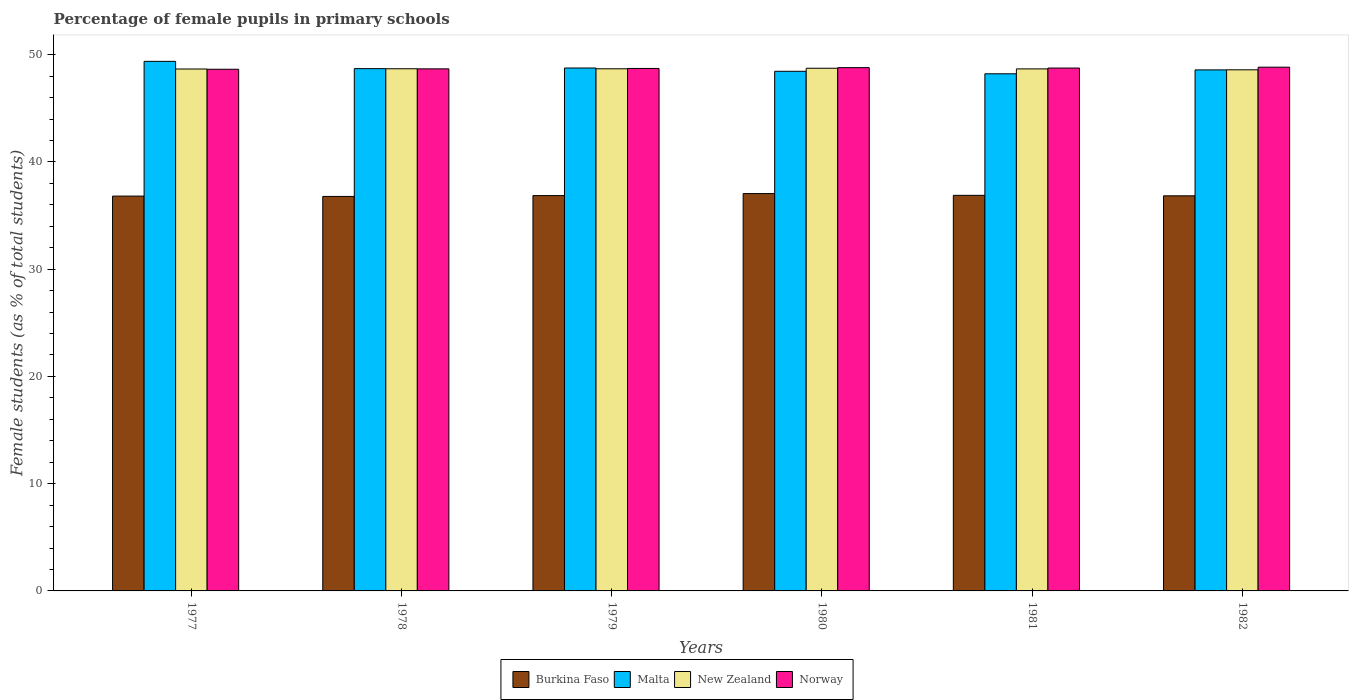Are the number of bars on each tick of the X-axis equal?
Offer a very short reply. Yes. How many bars are there on the 6th tick from the left?
Give a very brief answer. 4. How many bars are there on the 1st tick from the right?
Keep it short and to the point. 4. What is the percentage of female pupils in primary schools in Malta in 1981?
Make the answer very short. 48.22. Across all years, what is the maximum percentage of female pupils in primary schools in New Zealand?
Provide a short and direct response. 48.74. Across all years, what is the minimum percentage of female pupils in primary schools in Norway?
Your answer should be compact. 48.65. In which year was the percentage of female pupils in primary schools in New Zealand minimum?
Give a very brief answer. 1982. What is the total percentage of female pupils in primary schools in New Zealand in the graph?
Provide a short and direct response. 292.06. What is the difference between the percentage of female pupils in primary schools in Norway in 1980 and that in 1981?
Offer a very short reply. 0.04. What is the difference between the percentage of female pupils in primary schools in New Zealand in 1978 and the percentage of female pupils in primary schools in Norway in 1980?
Make the answer very short. -0.1. What is the average percentage of female pupils in primary schools in Burkina Faso per year?
Offer a very short reply. 36.88. In the year 1981, what is the difference between the percentage of female pupils in primary schools in New Zealand and percentage of female pupils in primary schools in Burkina Faso?
Offer a very short reply. 11.79. In how many years, is the percentage of female pupils in primary schools in New Zealand greater than 42 %?
Ensure brevity in your answer.  6. What is the ratio of the percentage of female pupils in primary schools in Malta in 1977 to that in 1981?
Your response must be concise. 1.02. What is the difference between the highest and the second highest percentage of female pupils in primary schools in Burkina Faso?
Keep it short and to the point. 0.16. What is the difference between the highest and the lowest percentage of female pupils in primary schools in New Zealand?
Provide a succinct answer. 0.14. In how many years, is the percentage of female pupils in primary schools in Burkina Faso greater than the average percentage of female pupils in primary schools in Burkina Faso taken over all years?
Keep it short and to the point. 2. Is it the case that in every year, the sum of the percentage of female pupils in primary schools in Malta and percentage of female pupils in primary schools in Norway is greater than the sum of percentage of female pupils in primary schools in Burkina Faso and percentage of female pupils in primary schools in New Zealand?
Provide a short and direct response. Yes. What does the 2nd bar from the left in 1977 represents?
Ensure brevity in your answer.  Malta. Is it the case that in every year, the sum of the percentage of female pupils in primary schools in Malta and percentage of female pupils in primary schools in Burkina Faso is greater than the percentage of female pupils in primary schools in Norway?
Your answer should be compact. Yes. How many bars are there?
Offer a very short reply. 24. Are all the bars in the graph horizontal?
Keep it short and to the point. No. What is the difference between two consecutive major ticks on the Y-axis?
Offer a very short reply. 10. Does the graph contain any zero values?
Keep it short and to the point. No. Does the graph contain grids?
Offer a very short reply. No. Where does the legend appear in the graph?
Keep it short and to the point. Bottom center. What is the title of the graph?
Your response must be concise. Percentage of female pupils in primary schools. Does "World" appear as one of the legend labels in the graph?
Offer a terse response. No. What is the label or title of the X-axis?
Provide a succinct answer. Years. What is the label or title of the Y-axis?
Make the answer very short. Female students (as % of total students). What is the Female students (as % of total students) of Burkina Faso in 1977?
Your answer should be very brief. 36.82. What is the Female students (as % of total students) of Malta in 1977?
Your answer should be very brief. 49.38. What is the Female students (as % of total students) of New Zealand in 1977?
Provide a short and direct response. 48.67. What is the Female students (as % of total students) in Norway in 1977?
Offer a very short reply. 48.65. What is the Female students (as % of total students) of Burkina Faso in 1978?
Your response must be concise. 36.79. What is the Female students (as % of total students) in Malta in 1978?
Provide a short and direct response. 48.7. What is the Female students (as % of total students) of New Zealand in 1978?
Offer a very short reply. 48.69. What is the Female students (as % of total students) in Norway in 1978?
Provide a short and direct response. 48.68. What is the Female students (as % of total students) in Burkina Faso in 1979?
Your response must be concise. 36.87. What is the Female students (as % of total students) of Malta in 1979?
Provide a succinct answer. 48.76. What is the Female students (as % of total students) of New Zealand in 1979?
Give a very brief answer. 48.69. What is the Female students (as % of total students) in Norway in 1979?
Keep it short and to the point. 48.72. What is the Female students (as % of total students) of Burkina Faso in 1980?
Provide a succinct answer. 37.05. What is the Female students (as % of total students) in Malta in 1980?
Make the answer very short. 48.46. What is the Female students (as % of total students) of New Zealand in 1980?
Your answer should be compact. 48.74. What is the Female students (as % of total students) of Norway in 1980?
Your answer should be very brief. 48.8. What is the Female students (as % of total students) in Burkina Faso in 1981?
Keep it short and to the point. 36.89. What is the Female students (as % of total students) in Malta in 1981?
Offer a terse response. 48.22. What is the Female students (as % of total students) in New Zealand in 1981?
Provide a succinct answer. 48.68. What is the Female students (as % of total students) in Norway in 1981?
Your answer should be very brief. 48.76. What is the Female students (as % of total students) in Burkina Faso in 1982?
Your answer should be compact. 36.84. What is the Female students (as % of total students) in Malta in 1982?
Give a very brief answer. 48.59. What is the Female students (as % of total students) in New Zealand in 1982?
Give a very brief answer. 48.59. What is the Female students (as % of total students) of Norway in 1982?
Provide a short and direct response. 48.84. Across all years, what is the maximum Female students (as % of total students) in Burkina Faso?
Offer a terse response. 37.05. Across all years, what is the maximum Female students (as % of total students) of Malta?
Offer a terse response. 49.38. Across all years, what is the maximum Female students (as % of total students) of New Zealand?
Make the answer very short. 48.74. Across all years, what is the maximum Female students (as % of total students) of Norway?
Provide a short and direct response. 48.84. Across all years, what is the minimum Female students (as % of total students) of Burkina Faso?
Keep it short and to the point. 36.79. Across all years, what is the minimum Female students (as % of total students) of Malta?
Your response must be concise. 48.22. Across all years, what is the minimum Female students (as % of total students) in New Zealand?
Give a very brief answer. 48.59. Across all years, what is the minimum Female students (as % of total students) in Norway?
Give a very brief answer. 48.65. What is the total Female students (as % of total students) of Burkina Faso in the graph?
Provide a short and direct response. 221.26. What is the total Female students (as % of total students) of Malta in the graph?
Your answer should be compact. 292.11. What is the total Female students (as % of total students) of New Zealand in the graph?
Offer a terse response. 292.06. What is the total Female students (as % of total students) of Norway in the graph?
Your answer should be very brief. 292.44. What is the difference between the Female students (as % of total students) of Burkina Faso in 1977 and that in 1978?
Make the answer very short. 0.03. What is the difference between the Female students (as % of total students) in Malta in 1977 and that in 1978?
Your response must be concise. 0.68. What is the difference between the Female students (as % of total students) in New Zealand in 1977 and that in 1978?
Your response must be concise. -0.02. What is the difference between the Female students (as % of total students) of Norway in 1977 and that in 1978?
Keep it short and to the point. -0.04. What is the difference between the Female students (as % of total students) of Burkina Faso in 1977 and that in 1979?
Your response must be concise. -0.05. What is the difference between the Female students (as % of total students) in Malta in 1977 and that in 1979?
Your answer should be very brief. 0.62. What is the difference between the Female students (as % of total students) in New Zealand in 1977 and that in 1979?
Your response must be concise. -0.02. What is the difference between the Female students (as % of total students) in Norway in 1977 and that in 1979?
Offer a terse response. -0.07. What is the difference between the Female students (as % of total students) in Burkina Faso in 1977 and that in 1980?
Offer a terse response. -0.23. What is the difference between the Female students (as % of total students) in Malta in 1977 and that in 1980?
Offer a very short reply. 0.93. What is the difference between the Female students (as % of total students) in New Zealand in 1977 and that in 1980?
Give a very brief answer. -0.07. What is the difference between the Female students (as % of total students) of Norway in 1977 and that in 1980?
Your response must be concise. -0.15. What is the difference between the Female students (as % of total students) in Burkina Faso in 1977 and that in 1981?
Make the answer very short. -0.07. What is the difference between the Female students (as % of total students) in Malta in 1977 and that in 1981?
Your answer should be compact. 1.16. What is the difference between the Female students (as % of total students) in New Zealand in 1977 and that in 1981?
Ensure brevity in your answer.  -0.01. What is the difference between the Female students (as % of total students) of Norway in 1977 and that in 1981?
Ensure brevity in your answer.  -0.11. What is the difference between the Female students (as % of total students) of Burkina Faso in 1977 and that in 1982?
Give a very brief answer. -0.03. What is the difference between the Female students (as % of total students) in Malta in 1977 and that in 1982?
Keep it short and to the point. 0.8. What is the difference between the Female students (as % of total students) in New Zealand in 1977 and that in 1982?
Make the answer very short. 0.07. What is the difference between the Female students (as % of total students) of Norway in 1977 and that in 1982?
Offer a terse response. -0.19. What is the difference between the Female students (as % of total students) of Burkina Faso in 1978 and that in 1979?
Ensure brevity in your answer.  -0.08. What is the difference between the Female students (as % of total students) of Malta in 1978 and that in 1979?
Offer a terse response. -0.06. What is the difference between the Female students (as % of total students) in New Zealand in 1978 and that in 1979?
Provide a short and direct response. 0. What is the difference between the Female students (as % of total students) in Norway in 1978 and that in 1979?
Offer a terse response. -0.04. What is the difference between the Female students (as % of total students) of Burkina Faso in 1978 and that in 1980?
Your answer should be very brief. -0.26. What is the difference between the Female students (as % of total students) in Malta in 1978 and that in 1980?
Offer a very short reply. 0.25. What is the difference between the Female students (as % of total students) of New Zealand in 1978 and that in 1980?
Your response must be concise. -0.05. What is the difference between the Female students (as % of total students) of Norway in 1978 and that in 1980?
Give a very brief answer. -0.11. What is the difference between the Female students (as % of total students) of Burkina Faso in 1978 and that in 1981?
Provide a succinct answer. -0.1. What is the difference between the Female students (as % of total students) of Malta in 1978 and that in 1981?
Offer a terse response. 0.48. What is the difference between the Female students (as % of total students) in New Zealand in 1978 and that in 1981?
Offer a terse response. 0.01. What is the difference between the Female students (as % of total students) of Norway in 1978 and that in 1981?
Your answer should be very brief. -0.08. What is the difference between the Female students (as % of total students) of Burkina Faso in 1978 and that in 1982?
Your answer should be very brief. -0.06. What is the difference between the Female students (as % of total students) in Malta in 1978 and that in 1982?
Keep it short and to the point. 0.12. What is the difference between the Female students (as % of total students) in New Zealand in 1978 and that in 1982?
Keep it short and to the point. 0.1. What is the difference between the Female students (as % of total students) in Norway in 1978 and that in 1982?
Ensure brevity in your answer.  -0.16. What is the difference between the Female students (as % of total students) of Burkina Faso in 1979 and that in 1980?
Your answer should be very brief. -0.19. What is the difference between the Female students (as % of total students) in Malta in 1979 and that in 1980?
Ensure brevity in your answer.  0.31. What is the difference between the Female students (as % of total students) of New Zealand in 1979 and that in 1980?
Your answer should be very brief. -0.05. What is the difference between the Female students (as % of total students) in Norway in 1979 and that in 1980?
Your answer should be compact. -0.08. What is the difference between the Female students (as % of total students) in Burkina Faso in 1979 and that in 1981?
Your response must be concise. -0.02. What is the difference between the Female students (as % of total students) of Malta in 1979 and that in 1981?
Make the answer very short. 0.54. What is the difference between the Female students (as % of total students) of Norway in 1979 and that in 1981?
Your response must be concise. -0.04. What is the difference between the Female students (as % of total students) in Burkina Faso in 1979 and that in 1982?
Provide a short and direct response. 0.02. What is the difference between the Female students (as % of total students) of Malta in 1979 and that in 1982?
Provide a short and direct response. 0.18. What is the difference between the Female students (as % of total students) in New Zealand in 1979 and that in 1982?
Offer a very short reply. 0.09. What is the difference between the Female students (as % of total students) in Norway in 1979 and that in 1982?
Your answer should be compact. -0.12. What is the difference between the Female students (as % of total students) in Burkina Faso in 1980 and that in 1981?
Your response must be concise. 0.16. What is the difference between the Female students (as % of total students) of Malta in 1980 and that in 1981?
Your answer should be compact. 0.23. What is the difference between the Female students (as % of total students) in New Zealand in 1980 and that in 1981?
Your response must be concise. 0.06. What is the difference between the Female students (as % of total students) in Norway in 1980 and that in 1981?
Provide a succinct answer. 0.04. What is the difference between the Female students (as % of total students) in Burkina Faso in 1980 and that in 1982?
Provide a short and direct response. 0.21. What is the difference between the Female students (as % of total students) in Malta in 1980 and that in 1982?
Your response must be concise. -0.13. What is the difference between the Female students (as % of total students) in New Zealand in 1980 and that in 1982?
Your response must be concise. 0.14. What is the difference between the Female students (as % of total students) of Norway in 1980 and that in 1982?
Your answer should be compact. -0.04. What is the difference between the Female students (as % of total students) in Burkina Faso in 1981 and that in 1982?
Your response must be concise. 0.05. What is the difference between the Female students (as % of total students) in Malta in 1981 and that in 1982?
Your answer should be compact. -0.36. What is the difference between the Female students (as % of total students) of New Zealand in 1981 and that in 1982?
Your answer should be compact. 0.08. What is the difference between the Female students (as % of total students) of Norway in 1981 and that in 1982?
Offer a terse response. -0.08. What is the difference between the Female students (as % of total students) of Burkina Faso in 1977 and the Female students (as % of total students) of Malta in 1978?
Your response must be concise. -11.89. What is the difference between the Female students (as % of total students) of Burkina Faso in 1977 and the Female students (as % of total students) of New Zealand in 1978?
Provide a succinct answer. -11.87. What is the difference between the Female students (as % of total students) in Burkina Faso in 1977 and the Female students (as % of total students) in Norway in 1978?
Make the answer very short. -11.87. What is the difference between the Female students (as % of total students) of Malta in 1977 and the Female students (as % of total students) of New Zealand in 1978?
Keep it short and to the point. 0.69. What is the difference between the Female students (as % of total students) of Malta in 1977 and the Female students (as % of total students) of Norway in 1978?
Your response must be concise. 0.7. What is the difference between the Female students (as % of total students) of New Zealand in 1977 and the Female students (as % of total students) of Norway in 1978?
Provide a succinct answer. -0.01. What is the difference between the Female students (as % of total students) in Burkina Faso in 1977 and the Female students (as % of total students) in Malta in 1979?
Keep it short and to the point. -11.94. What is the difference between the Female students (as % of total students) in Burkina Faso in 1977 and the Female students (as % of total students) in New Zealand in 1979?
Provide a short and direct response. -11.87. What is the difference between the Female students (as % of total students) in Burkina Faso in 1977 and the Female students (as % of total students) in Norway in 1979?
Offer a very short reply. -11.9. What is the difference between the Female students (as % of total students) of Malta in 1977 and the Female students (as % of total students) of New Zealand in 1979?
Make the answer very short. 0.69. What is the difference between the Female students (as % of total students) of Malta in 1977 and the Female students (as % of total students) of Norway in 1979?
Keep it short and to the point. 0.66. What is the difference between the Female students (as % of total students) of New Zealand in 1977 and the Female students (as % of total students) of Norway in 1979?
Offer a very short reply. -0.05. What is the difference between the Female students (as % of total students) in Burkina Faso in 1977 and the Female students (as % of total students) in Malta in 1980?
Provide a short and direct response. -11.64. What is the difference between the Female students (as % of total students) in Burkina Faso in 1977 and the Female students (as % of total students) in New Zealand in 1980?
Provide a short and direct response. -11.92. What is the difference between the Female students (as % of total students) of Burkina Faso in 1977 and the Female students (as % of total students) of Norway in 1980?
Provide a succinct answer. -11.98. What is the difference between the Female students (as % of total students) in Malta in 1977 and the Female students (as % of total students) in New Zealand in 1980?
Offer a very short reply. 0.64. What is the difference between the Female students (as % of total students) in Malta in 1977 and the Female students (as % of total students) in Norway in 1980?
Your answer should be very brief. 0.59. What is the difference between the Female students (as % of total students) in New Zealand in 1977 and the Female students (as % of total students) in Norway in 1980?
Make the answer very short. -0.13. What is the difference between the Female students (as % of total students) in Burkina Faso in 1977 and the Female students (as % of total students) in Malta in 1981?
Your answer should be very brief. -11.4. What is the difference between the Female students (as % of total students) in Burkina Faso in 1977 and the Female students (as % of total students) in New Zealand in 1981?
Ensure brevity in your answer.  -11.86. What is the difference between the Female students (as % of total students) in Burkina Faso in 1977 and the Female students (as % of total students) in Norway in 1981?
Ensure brevity in your answer.  -11.94. What is the difference between the Female students (as % of total students) of Malta in 1977 and the Female students (as % of total students) of New Zealand in 1981?
Make the answer very short. 0.7. What is the difference between the Female students (as % of total students) of Malta in 1977 and the Female students (as % of total students) of Norway in 1981?
Your answer should be very brief. 0.62. What is the difference between the Female students (as % of total students) of New Zealand in 1977 and the Female students (as % of total students) of Norway in 1981?
Keep it short and to the point. -0.09. What is the difference between the Female students (as % of total students) in Burkina Faso in 1977 and the Female students (as % of total students) in Malta in 1982?
Make the answer very short. -11.77. What is the difference between the Female students (as % of total students) of Burkina Faso in 1977 and the Female students (as % of total students) of New Zealand in 1982?
Give a very brief answer. -11.78. What is the difference between the Female students (as % of total students) of Burkina Faso in 1977 and the Female students (as % of total students) of Norway in 1982?
Offer a very short reply. -12.02. What is the difference between the Female students (as % of total students) of Malta in 1977 and the Female students (as % of total students) of New Zealand in 1982?
Keep it short and to the point. 0.79. What is the difference between the Female students (as % of total students) of Malta in 1977 and the Female students (as % of total students) of Norway in 1982?
Provide a succinct answer. 0.54. What is the difference between the Female students (as % of total students) in New Zealand in 1977 and the Female students (as % of total students) in Norway in 1982?
Keep it short and to the point. -0.17. What is the difference between the Female students (as % of total students) in Burkina Faso in 1978 and the Female students (as % of total students) in Malta in 1979?
Provide a short and direct response. -11.97. What is the difference between the Female students (as % of total students) in Burkina Faso in 1978 and the Female students (as % of total students) in New Zealand in 1979?
Offer a terse response. -11.9. What is the difference between the Female students (as % of total students) of Burkina Faso in 1978 and the Female students (as % of total students) of Norway in 1979?
Provide a succinct answer. -11.93. What is the difference between the Female students (as % of total students) of Malta in 1978 and the Female students (as % of total students) of New Zealand in 1979?
Offer a very short reply. 0.01. What is the difference between the Female students (as % of total students) of Malta in 1978 and the Female students (as % of total students) of Norway in 1979?
Make the answer very short. -0.02. What is the difference between the Female students (as % of total students) in New Zealand in 1978 and the Female students (as % of total students) in Norway in 1979?
Your response must be concise. -0.03. What is the difference between the Female students (as % of total students) in Burkina Faso in 1978 and the Female students (as % of total students) in Malta in 1980?
Offer a terse response. -11.67. What is the difference between the Female students (as % of total students) of Burkina Faso in 1978 and the Female students (as % of total students) of New Zealand in 1980?
Provide a succinct answer. -11.95. What is the difference between the Female students (as % of total students) of Burkina Faso in 1978 and the Female students (as % of total students) of Norway in 1980?
Provide a short and direct response. -12.01. What is the difference between the Female students (as % of total students) of Malta in 1978 and the Female students (as % of total students) of New Zealand in 1980?
Give a very brief answer. -0.04. What is the difference between the Female students (as % of total students) in Malta in 1978 and the Female students (as % of total students) in Norway in 1980?
Give a very brief answer. -0.09. What is the difference between the Female students (as % of total students) in New Zealand in 1978 and the Female students (as % of total students) in Norway in 1980?
Ensure brevity in your answer.  -0.1. What is the difference between the Female students (as % of total students) in Burkina Faso in 1978 and the Female students (as % of total students) in Malta in 1981?
Your answer should be very brief. -11.44. What is the difference between the Female students (as % of total students) in Burkina Faso in 1978 and the Female students (as % of total students) in New Zealand in 1981?
Give a very brief answer. -11.89. What is the difference between the Female students (as % of total students) of Burkina Faso in 1978 and the Female students (as % of total students) of Norway in 1981?
Provide a short and direct response. -11.97. What is the difference between the Female students (as % of total students) of Malta in 1978 and the Female students (as % of total students) of New Zealand in 1981?
Your answer should be very brief. 0.02. What is the difference between the Female students (as % of total students) of Malta in 1978 and the Female students (as % of total students) of Norway in 1981?
Provide a short and direct response. -0.06. What is the difference between the Female students (as % of total students) of New Zealand in 1978 and the Female students (as % of total students) of Norway in 1981?
Offer a terse response. -0.07. What is the difference between the Female students (as % of total students) in Burkina Faso in 1978 and the Female students (as % of total students) in Malta in 1982?
Ensure brevity in your answer.  -11.8. What is the difference between the Female students (as % of total students) in Burkina Faso in 1978 and the Female students (as % of total students) in New Zealand in 1982?
Ensure brevity in your answer.  -11.81. What is the difference between the Female students (as % of total students) in Burkina Faso in 1978 and the Female students (as % of total students) in Norway in 1982?
Make the answer very short. -12.05. What is the difference between the Female students (as % of total students) in Malta in 1978 and the Female students (as % of total students) in New Zealand in 1982?
Your answer should be very brief. 0.11. What is the difference between the Female students (as % of total students) in Malta in 1978 and the Female students (as % of total students) in Norway in 1982?
Ensure brevity in your answer.  -0.14. What is the difference between the Female students (as % of total students) of New Zealand in 1978 and the Female students (as % of total students) of Norway in 1982?
Your response must be concise. -0.15. What is the difference between the Female students (as % of total students) in Burkina Faso in 1979 and the Female students (as % of total students) in Malta in 1980?
Make the answer very short. -11.59. What is the difference between the Female students (as % of total students) of Burkina Faso in 1979 and the Female students (as % of total students) of New Zealand in 1980?
Your answer should be compact. -11.87. What is the difference between the Female students (as % of total students) of Burkina Faso in 1979 and the Female students (as % of total students) of Norway in 1980?
Your answer should be compact. -11.93. What is the difference between the Female students (as % of total students) of Malta in 1979 and the Female students (as % of total students) of New Zealand in 1980?
Ensure brevity in your answer.  0.02. What is the difference between the Female students (as % of total students) in Malta in 1979 and the Female students (as % of total students) in Norway in 1980?
Your answer should be compact. -0.04. What is the difference between the Female students (as % of total students) of New Zealand in 1979 and the Female students (as % of total students) of Norway in 1980?
Provide a short and direct response. -0.11. What is the difference between the Female students (as % of total students) in Burkina Faso in 1979 and the Female students (as % of total students) in Malta in 1981?
Ensure brevity in your answer.  -11.36. What is the difference between the Female students (as % of total students) in Burkina Faso in 1979 and the Female students (as % of total students) in New Zealand in 1981?
Provide a short and direct response. -11.81. What is the difference between the Female students (as % of total students) of Burkina Faso in 1979 and the Female students (as % of total students) of Norway in 1981?
Keep it short and to the point. -11.89. What is the difference between the Female students (as % of total students) of Malta in 1979 and the Female students (as % of total students) of New Zealand in 1981?
Give a very brief answer. 0.08. What is the difference between the Female students (as % of total students) in Malta in 1979 and the Female students (as % of total students) in Norway in 1981?
Ensure brevity in your answer.  0. What is the difference between the Female students (as % of total students) of New Zealand in 1979 and the Female students (as % of total students) of Norway in 1981?
Make the answer very short. -0.07. What is the difference between the Female students (as % of total students) in Burkina Faso in 1979 and the Female students (as % of total students) in Malta in 1982?
Your answer should be very brief. -11.72. What is the difference between the Female students (as % of total students) of Burkina Faso in 1979 and the Female students (as % of total students) of New Zealand in 1982?
Offer a very short reply. -11.73. What is the difference between the Female students (as % of total students) in Burkina Faso in 1979 and the Female students (as % of total students) in Norway in 1982?
Your answer should be very brief. -11.97. What is the difference between the Female students (as % of total students) of Malta in 1979 and the Female students (as % of total students) of New Zealand in 1982?
Make the answer very short. 0.17. What is the difference between the Female students (as % of total students) in Malta in 1979 and the Female students (as % of total students) in Norway in 1982?
Your answer should be very brief. -0.08. What is the difference between the Female students (as % of total students) in New Zealand in 1979 and the Female students (as % of total students) in Norway in 1982?
Provide a short and direct response. -0.15. What is the difference between the Female students (as % of total students) in Burkina Faso in 1980 and the Female students (as % of total students) in Malta in 1981?
Ensure brevity in your answer.  -11.17. What is the difference between the Female students (as % of total students) in Burkina Faso in 1980 and the Female students (as % of total students) in New Zealand in 1981?
Your response must be concise. -11.63. What is the difference between the Female students (as % of total students) of Burkina Faso in 1980 and the Female students (as % of total students) of Norway in 1981?
Your answer should be compact. -11.71. What is the difference between the Female students (as % of total students) in Malta in 1980 and the Female students (as % of total students) in New Zealand in 1981?
Provide a succinct answer. -0.22. What is the difference between the Female students (as % of total students) of Malta in 1980 and the Female students (as % of total students) of Norway in 1981?
Your answer should be compact. -0.3. What is the difference between the Female students (as % of total students) in New Zealand in 1980 and the Female students (as % of total students) in Norway in 1981?
Your response must be concise. -0.02. What is the difference between the Female students (as % of total students) in Burkina Faso in 1980 and the Female students (as % of total students) in Malta in 1982?
Your answer should be very brief. -11.53. What is the difference between the Female students (as % of total students) of Burkina Faso in 1980 and the Female students (as % of total students) of New Zealand in 1982?
Give a very brief answer. -11.54. What is the difference between the Female students (as % of total students) of Burkina Faso in 1980 and the Female students (as % of total students) of Norway in 1982?
Provide a short and direct response. -11.79. What is the difference between the Female students (as % of total students) of Malta in 1980 and the Female students (as % of total students) of New Zealand in 1982?
Your response must be concise. -0.14. What is the difference between the Female students (as % of total students) in Malta in 1980 and the Female students (as % of total students) in Norway in 1982?
Ensure brevity in your answer.  -0.38. What is the difference between the Female students (as % of total students) in New Zealand in 1980 and the Female students (as % of total students) in Norway in 1982?
Provide a succinct answer. -0.1. What is the difference between the Female students (as % of total students) in Burkina Faso in 1981 and the Female students (as % of total students) in Malta in 1982?
Provide a short and direct response. -11.7. What is the difference between the Female students (as % of total students) in Burkina Faso in 1981 and the Female students (as % of total students) in New Zealand in 1982?
Provide a succinct answer. -11.71. What is the difference between the Female students (as % of total students) in Burkina Faso in 1981 and the Female students (as % of total students) in Norway in 1982?
Ensure brevity in your answer.  -11.95. What is the difference between the Female students (as % of total students) in Malta in 1981 and the Female students (as % of total students) in New Zealand in 1982?
Give a very brief answer. -0.37. What is the difference between the Female students (as % of total students) in Malta in 1981 and the Female students (as % of total students) in Norway in 1982?
Your response must be concise. -0.62. What is the difference between the Female students (as % of total students) in New Zealand in 1981 and the Female students (as % of total students) in Norway in 1982?
Your answer should be very brief. -0.16. What is the average Female students (as % of total students) of Burkina Faso per year?
Ensure brevity in your answer.  36.88. What is the average Female students (as % of total students) of Malta per year?
Your response must be concise. 48.69. What is the average Female students (as % of total students) of New Zealand per year?
Your answer should be very brief. 48.68. What is the average Female students (as % of total students) of Norway per year?
Offer a very short reply. 48.74. In the year 1977, what is the difference between the Female students (as % of total students) in Burkina Faso and Female students (as % of total students) in Malta?
Your answer should be very brief. -12.56. In the year 1977, what is the difference between the Female students (as % of total students) of Burkina Faso and Female students (as % of total students) of New Zealand?
Offer a very short reply. -11.85. In the year 1977, what is the difference between the Female students (as % of total students) of Burkina Faso and Female students (as % of total students) of Norway?
Provide a short and direct response. -11.83. In the year 1977, what is the difference between the Female students (as % of total students) of Malta and Female students (as % of total students) of New Zealand?
Give a very brief answer. 0.71. In the year 1977, what is the difference between the Female students (as % of total students) in Malta and Female students (as % of total students) in Norway?
Provide a short and direct response. 0.74. In the year 1977, what is the difference between the Female students (as % of total students) of New Zealand and Female students (as % of total students) of Norway?
Keep it short and to the point. 0.02. In the year 1978, what is the difference between the Female students (as % of total students) in Burkina Faso and Female students (as % of total students) in Malta?
Make the answer very short. -11.92. In the year 1978, what is the difference between the Female students (as % of total students) of Burkina Faso and Female students (as % of total students) of New Zealand?
Provide a short and direct response. -11.91. In the year 1978, what is the difference between the Female students (as % of total students) in Burkina Faso and Female students (as % of total students) in Norway?
Your answer should be compact. -11.9. In the year 1978, what is the difference between the Female students (as % of total students) in Malta and Female students (as % of total students) in New Zealand?
Offer a very short reply. 0.01. In the year 1978, what is the difference between the Female students (as % of total students) of Malta and Female students (as % of total students) of Norway?
Give a very brief answer. 0.02. In the year 1978, what is the difference between the Female students (as % of total students) in New Zealand and Female students (as % of total students) in Norway?
Your answer should be very brief. 0.01. In the year 1979, what is the difference between the Female students (as % of total students) in Burkina Faso and Female students (as % of total students) in Malta?
Provide a short and direct response. -11.9. In the year 1979, what is the difference between the Female students (as % of total students) in Burkina Faso and Female students (as % of total students) in New Zealand?
Ensure brevity in your answer.  -11.82. In the year 1979, what is the difference between the Female students (as % of total students) of Burkina Faso and Female students (as % of total students) of Norway?
Offer a very short reply. -11.85. In the year 1979, what is the difference between the Female students (as % of total students) of Malta and Female students (as % of total students) of New Zealand?
Your response must be concise. 0.07. In the year 1979, what is the difference between the Female students (as % of total students) of Malta and Female students (as % of total students) of Norway?
Offer a very short reply. 0.04. In the year 1979, what is the difference between the Female students (as % of total students) of New Zealand and Female students (as % of total students) of Norway?
Your response must be concise. -0.03. In the year 1980, what is the difference between the Female students (as % of total students) of Burkina Faso and Female students (as % of total students) of Malta?
Make the answer very short. -11.4. In the year 1980, what is the difference between the Female students (as % of total students) in Burkina Faso and Female students (as % of total students) in New Zealand?
Offer a terse response. -11.69. In the year 1980, what is the difference between the Female students (as % of total students) of Burkina Faso and Female students (as % of total students) of Norway?
Your response must be concise. -11.75. In the year 1980, what is the difference between the Female students (as % of total students) in Malta and Female students (as % of total students) in New Zealand?
Your response must be concise. -0.28. In the year 1980, what is the difference between the Female students (as % of total students) in Malta and Female students (as % of total students) in Norway?
Provide a succinct answer. -0.34. In the year 1980, what is the difference between the Female students (as % of total students) of New Zealand and Female students (as % of total students) of Norway?
Your response must be concise. -0.06. In the year 1981, what is the difference between the Female students (as % of total students) of Burkina Faso and Female students (as % of total students) of Malta?
Provide a succinct answer. -11.33. In the year 1981, what is the difference between the Female students (as % of total students) of Burkina Faso and Female students (as % of total students) of New Zealand?
Provide a short and direct response. -11.79. In the year 1981, what is the difference between the Female students (as % of total students) of Burkina Faso and Female students (as % of total students) of Norway?
Offer a very short reply. -11.87. In the year 1981, what is the difference between the Female students (as % of total students) of Malta and Female students (as % of total students) of New Zealand?
Provide a succinct answer. -0.46. In the year 1981, what is the difference between the Female students (as % of total students) in Malta and Female students (as % of total students) in Norway?
Provide a short and direct response. -0.54. In the year 1981, what is the difference between the Female students (as % of total students) of New Zealand and Female students (as % of total students) of Norway?
Provide a succinct answer. -0.08. In the year 1982, what is the difference between the Female students (as % of total students) in Burkina Faso and Female students (as % of total students) in Malta?
Provide a succinct answer. -11.74. In the year 1982, what is the difference between the Female students (as % of total students) of Burkina Faso and Female students (as % of total students) of New Zealand?
Keep it short and to the point. -11.75. In the year 1982, what is the difference between the Female students (as % of total students) in Burkina Faso and Female students (as % of total students) in Norway?
Offer a terse response. -12. In the year 1982, what is the difference between the Female students (as % of total students) in Malta and Female students (as % of total students) in New Zealand?
Make the answer very short. -0.01. In the year 1982, what is the difference between the Female students (as % of total students) in Malta and Female students (as % of total students) in Norway?
Your response must be concise. -0.25. In the year 1982, what is the difference between the Female students (as % of total students) in New Zealand and Female students (as % of total students) in Norway?
Make the answer very short. -0.25. What is the ratio of the Female students (as % of total students) of Malta in 1977 to that in 1978?
Give a very brief answer. 1.01. What is the ratio of the Female students (as % of total students) of Norway in 1977 to that in 1978?
Provide a succinct answer. 1. What is the ratio of the Female students (as % of total students) in Malta in 1977 to that in 1979?
Keep it short and to the point. 1.01. What is the ratio of the Female students (as % of total students) of Malta in 1977 to that in 1980?
Ensure brevity in your answer.  1.02. What is the ratio of the Female students (as % of total students) in New Zealand in 1977 to that in 1980?
Offer a very short reply. 1. What is the ratio of the Female students (as % of total students) of Burkina Faso in 1977 to that in 1981?
Your response must be concise. 1. What is the ratio of the Female students (as % of total students) in Malta in 1977 to that in 1981?
Offer a very short reply. 1.02. What is the ratio of the Female students (as % of total students) of Norway in 1977 to that in 1981?
Provide a succinct answer. 1. What is the ratio of the Female students (as % of total students) of Burkina Faso in 1977 to that in 1982?
Make the answer very short. 1. What is the ratio of the Female students (as % of total students) in Malta in 1977 to that in 1982?
Your answer should be very brief. 1.02. What is the ratio of the Female students (as % of total students) in New Zealand in 1977 to that in 1982?
Your answer should be compact. 1. What is the ratio of the Female students (as % of total students) of Burkina Faso in 1978 to that in 1979?
Offer a terse response. 1. What is the ratio of the Female students (as % of total students) in Malta in 1978 to that in 1979?
Your answer should be compact. 1. What is the ratio of the Female students (as % of total students) of New Zealand in 1978 to that in 1979?
Provide a succinct answer. 1. What is the ratio of the Female students (as % of total students) in Norway in 1978 to that in 1979?
Your response must be concise. 1. What is the ratio of the Female students (as % of total students) in Norway in 1978 to that in 1980?
Keep it short and to the point. 1. What is the ratio of the Female students (as % of total students) in Burkina Faso in 1978 to that in 1981?
Your answer should be very brief. 1. What is the ratio of the Female students (as % of total students) in Malta in 1978 to that in 1981?
Give a very brief answer. 1.01. What is the ratio of the Female students (as % of total students) in Burkina Faso in 1978 to that in 1982?
Offer a terse response. 1. What is the ratio of the Female students (as % of total students) in Burkina Faso in 1979 to that in 1980?
Make the answer very short. 0.99. What is the ratio of the Female students (as % of total students) of Malta in 1979 to that in 1980?
Offer a terse response. 1.01. What is the ratio of the Female students (as % of total students) of Malta in 1979 to that in 1981?
Make the answer very short. 1.01. What is the ratio of the Female students (as % of total students) in New Zealand in 1979 to that in 1981?
Your answer should be very brief. 1. What is the ratio of the Female students (as % of total students) in Norway in 1979 to that in 1981?
Provide a succinct answer. 1. What is the ratio of the Female students (as % of total students) in Burkina Faso in 1979 to that in 1982?
Offer a terse response. 1. What is the ratio of the Female students (as % of total students) in Norway in 1979 to that in 1982?
Give a very brief answer. 1. What is the ratio of the Female students (as % of total students) in Malta in 1980 to that in 1981?
Provide a short and direct response. 1. What is the ratio of the Female students (as % of total students) of New Zealand in 1980 to that in 1981?
Provide a succinct answer. 1. What is the ratio of the Female students (as % of total students) in Burkina Faso in 1980 to that in 1982?
Your response must be concise. 1.01. What is the ratio of the Female students (as % of total students) in Malta in 1980 to that in 1982?
Give a very brief answer. 1. What is the ratio of the Female students (as % of total students) of New Zealand in 1980 to that in 1982?
Your answer should be compact. 1. What is the difference between the highest and the second highest Female students (as % of total students) in Burkina Faso?
Your answer should be very brief. 0.16. What is the difference between the highest and the second highest Female students (as % of total students) in Malta?
Make the answer very short. 0.62. What is the difference between the highest and the second highest Female students (as % of total students) in New Zealand?
Offer a very short reply. 0.05. What is the difference between the highest and the second highest Female students (as % of total students) of Norway?
Offer a very short reply. 0.04. What is the difference between the highest and the lowest Female students (as % of total students) in Burkina Faso?
Offer a terse response. 0.26. What is the difference between the highest and the lowest Female students (as % of total students) in Malta?
Provide a short and direct response. 1.16. What is the difference between the highest and the lowest Female students (as % of total students) in New Zealand?
Provide a short and direct response. 0.14. What is the difference between the highest and the lowest Female students (as % of total students) of Norway?
Give a very brief answer. 0.19. 